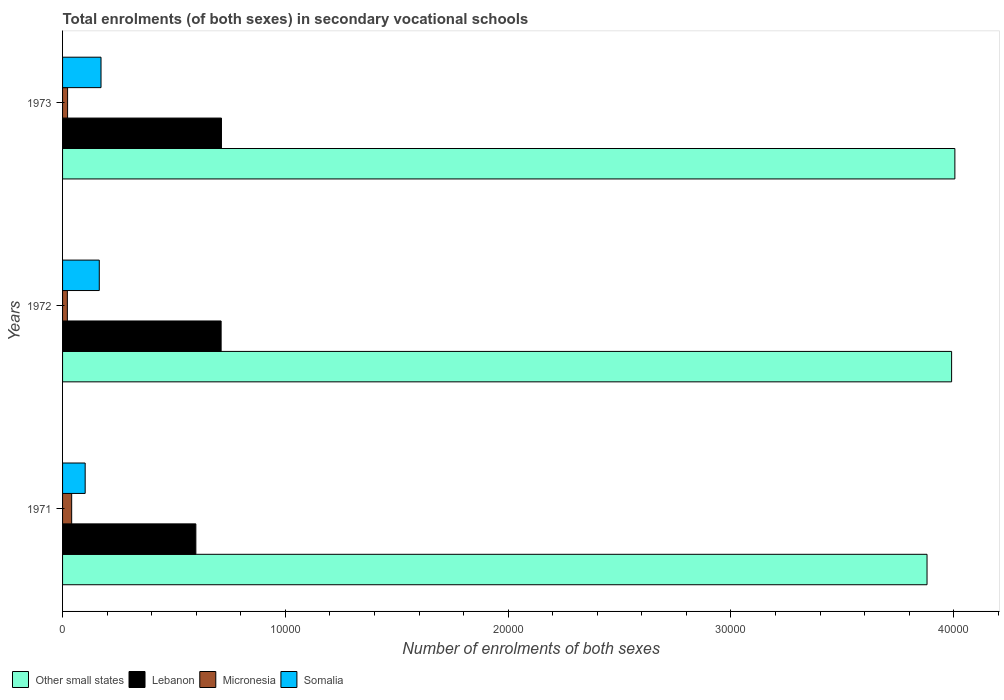How many different coloured bars are there?
Your answer should be very brief. 4. Are the number of bars per tick equal to the number of legend labels?
Ensure brevity in your answer.  Yes. Are the number of bars on each tick of the Y-axis equal?
Your response must be concise. Yes. How many bars are there on the 3rd tick from the bottom?
Your answer should be very brief. 4. In how many cases, is the number of bars for a given year not equal to the number of legend labels?
Your answer should be compact. 0. What is the number of enrolments in secondary schools in Lebanon in 1971?
Give a very brief answer. 5983. Across all years, what is the maximum number of enrolments in secondary schools in Micronesia?
Make the answer very short. 409. Across all years, what is the minimum number of enrolments in secondary schools in Other small states?
Ensure brevity in your answer.  3.88e+04. In which year was the number of enrolments in secondary schools in Other small states minimum?
Give a very brief answer. 1971. What is the total number of enrolments in secondary schools in Micronesia in the graph?
Give a very brief answer. 850. What is the difference between the number of enrolments in secondary schools in Micronesia in 1971 and the number of enrolments in secondary schools in Other small states in 1973?
Give a very brief answer. -3.96e+04. What is the average number of enrolments in secondary schools in Other small states per year?
Your response must be concise. 3.96e+04. In the year 1972, what is the difference between the number of enrolments in secondary schools in Somalia and number of enrolments in secondary schools in Other small states?
Your answer should be very brief. -3.83e+04. What is the ratio of the number of enrolments in secondary schools in Lebanon in 1971 to that in 1972?
Make the answer very short. 0.84. What is the difference between the highest and the second highest number of enrolments in secondary schools in Lebanon?
Offer a terse response. 16. What is the difference between the highest and the lowest number of enrolments in secondary schools in Micronesia?
Your answer should be compact. 194. Is the sum of the number of enrolments in secondary schools in Micronesia in 1971 and 1973 greater than the maximum number of enrolments in secondary schools in Other small states across all years?
Make the answer very short. No. What does the 1st bar from the top in 1972 represents?
Offer a very short reply. Somalia. What does the 1st bar from the bottom in 1972 represents?
Keep it short and to the point. Other small states. Is it the case that in every year, the sum of the number of enrolments in secondary schools in Somalia and number of enrolments in secondary schools in Micronesia is greater than the number of enrolments in secondary schools in Other small states?
Your answer should be very brief. No. What is the difference between two consecutive major ticks on the X-axis?
Your response must be concise. 10000. Are the values on the major ticks of X-axis written in scientific E-notation?
Offer a terse response. No. Where does the legend appear in the graph?
Your response must be concise. Bottom left. How are the legend labels stacked?
Ensure brevity in your answer.  Horizontal. What is the title of the graph?
Provide a short and direct response. Total enrolments (of both sexes) in secondary vocational schools. What is the label or title of the X-axis?
Give a very brief answer. Number of enrolments of both sexes. What is the Number of enrolments of both sexes of Other small states in 1971?
Your answer should be compact. 3.88e+04. What is the Number of enrolments of both sexes of Lebanon in 1971?
Make the answer very short. 5983. What is the Number of enrolments of both sexes in Micronesia in 1971?
Offer a very short reply. 409. What is the Number of enrolments of both sexes in Somalia in 1971?
Your answer should be very brief. 1015. What is the Number of enrolments of both sexes of Other small states in 1972?
Keep it short and to the point. 3.99e+04. What is the Number of enrolments of both sexes of Lebanon in 1972?
Give a very brief answer. 7117. What is the Number of enrolments of both sexes of Micronesia in 1972?
Your answer should be very brief. 215. What is the Number of enrolments of both sexes in Somalia in 1972?
Make the answer very short. 1648. What is the Number of enrolments of both sexes in Other small states in 1973?
Provide a short and direct response. 4.01e+04. What is the Number of enrolments of both sexes of Lebanon in 1973?
Provide a succinct answer. 7133. What is the Number of enrolments of both sexes in Micronesia in 1973?
Make the answer very short. 226. What is the Number of enrolments of both sexes of Somalia in 1973?
Offer a very short reply. 1726. Across all years, what is the maximum Number of enrolments of both sexes of Other small states?
Keep it short and to the point. 4.01e+04. Across all years, what is the maximum Number of enrolments of both sexes of Lebanon?
Give a very brief answer. 7133. Across all years, what is the maximum Number of enrolments of both sexes of Micronesia?
Make the answer very short. 409. Across all years, what is the maximum Number of enrolments of both sexes of Somalia?
Your answer should be very brief. 1726. Across all years, what is the minimum Number of enrolments of both sexes of Other small states?
Your response must be concise. 3.88e+04. Across all years, what is the minimum Number of enrolments of both sexes in Lebanon?
Give a very brief answer. 5983. Across all years, what is the minimum Number of enrolments of both sexes of Micronesia?
Your answer should be compact. 215. Across all years, what is the minimum Number of enrolments of both sexes of Somalia?
Offer a very short reply. 1015. What is the total Number of enrolments of both sexes in Other small states in the graph?
Your answer should be compact. 1.19e+05. What is the total Number of enrolments of both sexes of Lebanon in the graph?
Offer a very short reply. 2.02e+04. What is the total Number of enrolments of both sexes in Micronesia in the graph?
Offer a very short reply. 850. What is the total Number of enrolments of both sexes in Somalia in the graph?
Give a very brief answer. 4389. What is the difference between the Number of enrolments of both sexes of Other small states in 1971 and that in 1972?
Your response must be concise. -1102.91. What is the difference between the Number of enrolments of both sexes in Lebanon in 1971 and that in 1972?
Provide a succinct answer. -1134. What is the difference between the Number of enrolments of both sexes of Micronesia in 1971 and that in 1972?
Keep it short and to the point. 194. What is the difference between the Number of enrolments of both sexes of Somalia in 1971 and that in 1972?
Give a very brief answer. -633. What is the difference between the Number of enrolments of both sexes of Other small states in 1971 and that in 1973?
Offer a terse response. -1249.68. What is the difference between the Number of enrolments of both sexes of Lebanon in 1971 and that in 1973?
Offer a terse response. -1150. What is the difference between the Number of enrolments of both sexes of Micronesia in 1971 and that in 1973?
Offer a very short reply. 183. What is the difference between the Number of enrolments of both sexes of Somalia in 1971 and that in 1973?
Keep it short and to the point. -711. What is the difference between the Number of enrolments of both sexes of Other small states in 1972 and that in 1973?
Provide a succinct answer. -146.76. What is the difference between the Number of enrolments of both sexes of Lebanon in 1972 and that in 1973?
Provide a succinct answer. -16. What is the difference between the Number of enrolments of both sexes of Somalia in 1972 and that in 1973?
Provide a short and direct response. -78. What is the difference between the Number of enrolments of both sexes in Other small states in 1971 and the Number of enrolments of both sexes in Lebanon in 1972?
Give a very brief answer. 3.17e+04. What is the difference between the Number of enrolments of both sexes in Other small states in 1971 and the Number of enrolments of both sexes in Micronesia in 1972?
Make the answer very short. 3.86e+04. What is the difference between the Number of enrolments of both sexes in Other small states in 1971 and the Number of enrolments of both sexes in Somalia in 1972?
Provide a succinct answer. 3.72e+04. What is the difference between the Number of enrolments of both sexes in Lebanon in 1971 and the Number of enrolments of both sexes in Micronesia in 1972?
Offer a very short reply. 5768. What is the difference between the Number of enrolments of both sexes in Lebanon in 1971 and the Number of enrolments of both sexes in Somalia in 1972?
Your answer should be compact. 4335. What is the difference between the Number of enrolments of both sexes in Micronesia in 1971 and the Number of enrolments of both sexes in Somalia in 1972?
Offer a terse response. -1239. What is the difference between the Number of enrolments of both sexes in Other small states in 1971 and the Number of enrolments of both sexes in Lebanon in 1973?
Your answer should be very brief. 3.17e+04. What is the difference between the Number of enrolments of both sexes in Other small states in 1971 and the Number of enrolments of both sexes in Micronesia in 1973?
Provide a short and direct response. 3.86e+04. What is the difference between the Number of enrolments of both sexes in Other small states in 1971 and the Number of enrolments of both sexes in Somalia in 1973?
Your answer should be compact. 3.71e+04. What is the difference between the Number of enrolments of both sexes of Lebanon in 1971 and the Number of enrolments of both sexes of Micronesia in 1973?
Keep it short and to the point. 5757. What is the difference between the Number of enrolments of both sexes in Lebanon in 1971 and the Number of enrolments of both sexes in Somalia in 1973?
Give a very brief answer. 4257. What is the difference between the Number of enrolments of both sexes in Micronesia in 1971 and the Number of enrolments of both sexes in Somalia in 1973?
Offer a terse response. -1317. What is the difference between the Number of enrolments of both sexes in Other small states in 1972 and the Number of enrolments of both sexes in Lebanon in 1973?
Keep it short and to the point. 3.28e+04. What is the difference between the Number of enrolments of both sexes in Other small states in 1972 and the Number of enrolments of both sexes in Micronesia in 1973?
Offer a very short reply. 3.97e+04. What is the difference between the Number of enrolments of both sexes of Other small states in 1972 and the Number of enrolments of both sexes of Somalia in 1973?
Offer a very short reply. 3.82e+04. What is the difference between the Number of enrolments of both sexes in Lebanon in 1972 and the Number of enrolments of both sexes in Micronesia in 1973?
Offer a terse response. 6891. What is the difference between the Number of enrolments of both sexes in Lebanon in 1972 and the Number of enrolments of both sexes in Somalia in 1973?
Offer a terse response. 5391. What is the difference between the Number of enrolments of both sexes of Micronesia in 1972 and the Number of enrolments of both sexes of Somalia in 1973?
Your response must be concise. -1511. What is the average Number of enrolments of both sexes in Other small states per year?
Provide a succinct answer. 3.96e+04. What is the average Number of enrolments of both sexes in Lebanon per year?
Give a very brief answer. 6744.33. What is the average Number of enrolments of both sexes in Micronesia per year?
Offer a terse response. 283.33. What is the average Number of enrolments of both sexes in Somalia per year?
Give a very brief answer. 1463. In the year 1971, what is the difference between the Number of enrolments of both sexes in Other small states and Number of enrolments of both sexes in Lebanon?
Make the answer very short. 3.28e+04. In the year 1971, what is the difference between the Number of enrolments of both sexes of Other small states and Number of enrolments of both sexes of Micronesia?
Your response must be concise. 3.84e+04. In the year 1971, what is the difference between the Number of enrolments of both sexes in Other small states and Number of enrolments of both sexes in Somalia?
Your answer should be compact. 3.78e+04. In the year 1971, what is the difference between the Number of enrolments of both sexes in Lebanon and Number of enrolments of both sexes in Micronesia?
Offer a very short reply. 5574. In the year 1971, what is the difference between the Number of enrolments of both sexes in Lebanon and Number of enrolments of both sexes in Somalia?
Ensure brevity in your answer.  4968. In the year 1971, what is the difference between the Number of enrolments of both sexes in Micronesia and Number of enrolments of both sexes in Somalia?
Offer a terse response. -606. In the year 1972, what is the difference between the Number of enrolments of both sexes in Other small states and Number of enrolments of both sexes in Lebanon?
Provide a short and direct response. 3.28e+04. In the year 1972, what is the difference between the Number of enrolments of both sexes in Other small states and Number of enrolments of both sexes in Micronesia?
Make the answer very short. 3.97e+04. In the year 1972, what is the difference between the Number of enrolments of both sexes in Other small states and Number of enrolments of both sexes in Somalia?
Your response must be concise. 3.83e+04. In the year 1972, what is the difference between the Number of enrolments of both sexes in Lebanon and Number of enrolments of both sexes in Micronesia?
Provide a succinct answer. 6902. In the year 1972, what is the difference between the Number of enrolments of both sexes of Lebanon and Number of enrolments of both sexes of Somalia?
Your answer should be very brief. 5469. In the year 1972, what is the difference between the Number of enrolments of both sexes of Micronesia and Number of enrolments of both sexes of Somalia?
Ensure brevity in your answer.  -1433. In the year 1973, what is the difference between the Number of enrolments of both sexes of Other small states and Number of enrolments of both sexes of Lebanon?
Your answer should be compact. 3.29e+04. In the year 1973, what is the difference between the Number of enrolments of both sexes of Other small states and Number of enrolments of both sexes of Micronesia?
Offer a very short reply. 3.98e+04. In the year 1973, what is the difference between the Number of enrolments of both sexes in Other small states and Number of enrolments of both sexes in Somalia?
Your answer should be very brief. 3.83e+04. In the year 1973, what is the difference between the Number of enrolments of both sexes of Lebanon and Number of enrolments of both sexes of Micronesia?
Make the answer very short. 6907. In the year 1973, what is the difference between the Number of enrolments of both sexes in Lebanon and Number of enrolments of both sexes in Somalia?
Ensure brevity in your answer.  5407. In the year 1973, what is the difference between the Number of enrolments of both sexes in Micronesia and Number of enrolments of both sexes in Somalia?
Make the answer very short. -1500. What is the ratio of the Number of enrolments of both sexes in Other small states in 1971 to that in 1972?
Offer a very short reply. 0.97. What is the ratio of the Number of enrolments of both sexes in Lebanon in 1971 to that in 1972?
Offer a terse response. 0.84. What is the ratio of the Number of enrolments of both sexes of Micronesia in 1971 to that in 1972?
Ensure brevity in your answer.  1.9. What is the ratio of the Number of enrolments of both sexes in Somalia in 1971 to that in 1972?
Offer a terse response. 0.62. What is the ratio of the Number of enrolments of both sexes in Other small states in 1971 to that in 1973?
Offer a terse response. 0.97. What is the ratio of the Number of enrolments of both sexes of Lebanon in 1971 to that in 1973?
Offer a very short reply. 0.84. What is the ratio of the Number of enrolments of both sexes of Micronesia in 1971 to that in 1973?
Make the answer very short. 1.81. What is the ratio of the Number of enrolments of both sexes of Somalia in 1971 to that in 1973?
Provide a succinct answer. 0.59. What is the ratio of the Number of enrolments of both sexes in Other small states in 1972 to that in 1973?
Give a very brief answer. 1. What is the ratio of the Number of enrolments of both sexes of Micronesia in 1972 to that in 1973?
Make the answer very short. 0.95. What is the ratio of the Number of enrolments of both sexes in Somalia in 1972 to that in 1973?
Provide a succinct answer. 0.95. What is the difference between the highest and the second highest Number of enrolments of both sexes in Other small states?
Offer a terse response. 146.76. What is the difference between the highest and the second highest Number of enrolments of both sexes in Lebanon?
Offer a terse response. 16. What is the difference between the highest and the second highest Number of enrolments of both sexes in Micronesia?
Your response must be concise. 183. What is the difference between the highest and the second highest Number of enrolments of both sexes of Somalia?
Your response must be concise. 78. What is the difference between the highest and the lowest Number of enrolments of both sexes of Other small states?
Your answer should be compact. 1249.68. What is the difference between the highest and the lowest Number of enrolments of both sexes of Lebanon?
Give a very brief answer. 1150. What is the difference between the highest and the lowest Number of enrolments of both sexes of Micronesia?
Make the answer very short. 194. What is the difference between the highest and the lowest Number of enrolments of both sexes of Somalia?
Your answer should be compact. 711. 